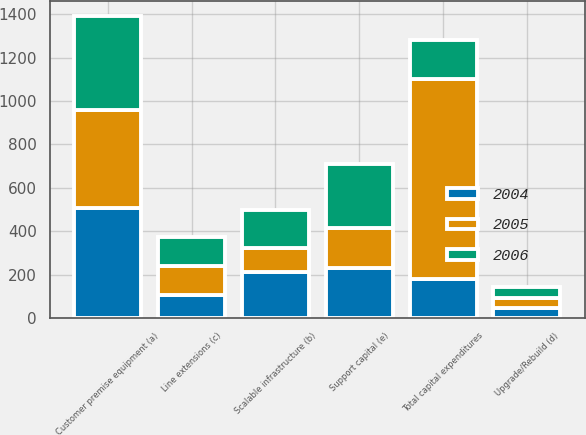Convert chart. <chart><loc_0><loc_0><loc_500><loc_500><stacked_bar_chart><ecel><fcel>Customer premise equipment (a)<fcel>Scalable infrastructure (b)<fcel>Line extensions (c)<fcel>Upgrade/Rebuild (d)<fcel>Support capital (e)<fcel>Total capital expenditures<nl><fcel>2004<fcel>507<fcel>214<fcel>107<fcel>45<fcel>230<fcel>179.5<nl><fcel>2006<fcel>434<fcel>174<fcel>134<fcel>49<fcel>297<fcel>179.5<nl><fcel>2005<fcel>451<fcel>108<fcel>131<fcel>49<fcel>185<fcel>924<nl></chart> 